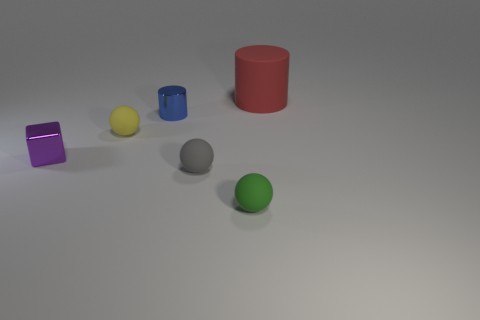Add 1 tiny green things. How many objects exist? 7 Subtract all cylinders. How many objects are left? 4 Add 6 gray balls. How many gray balls exist? 7 Subtract 0 blue balls. How many objects are left? 6 Subtract all tiny blocks. Subtract all tiny rubber balls. How many objects are left? 2 Add 4 small green balls. How many small green balls are left? 5 